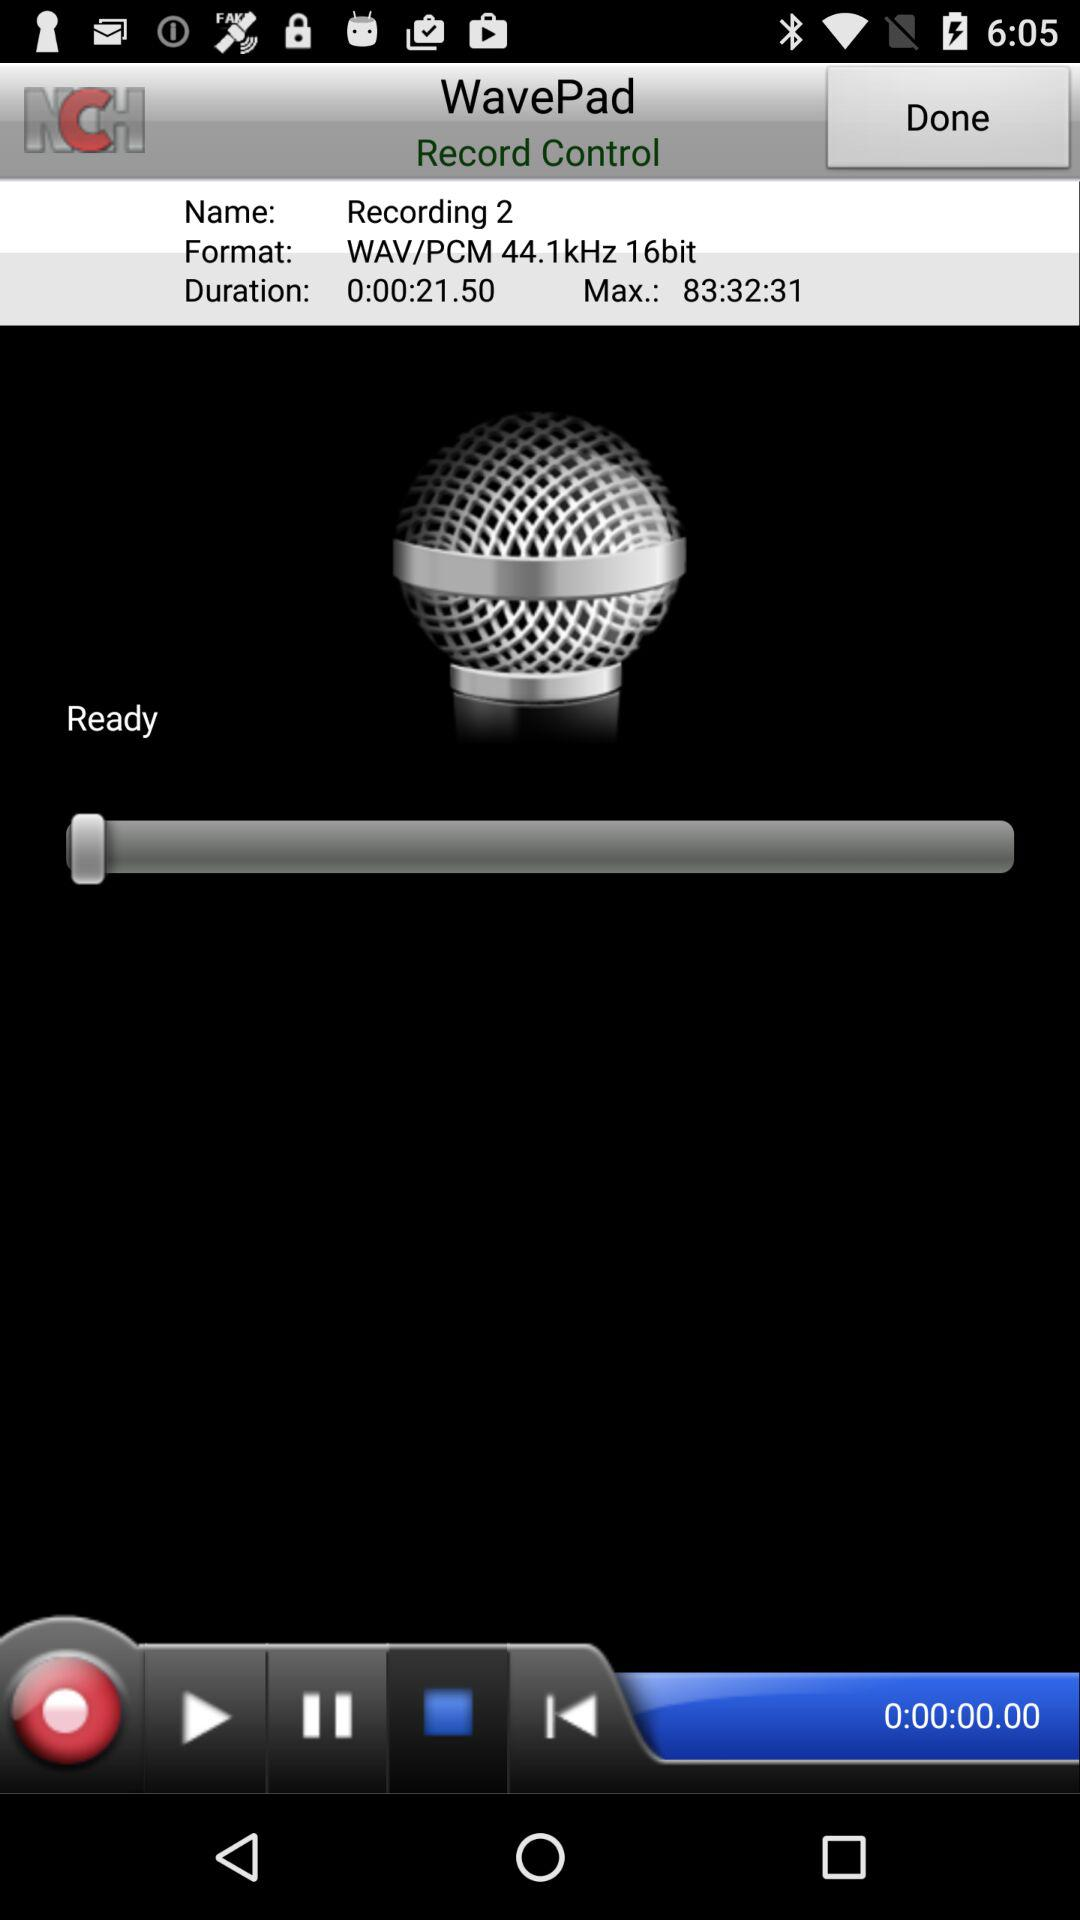What is the duration? The duration is 21.5 seconds. 